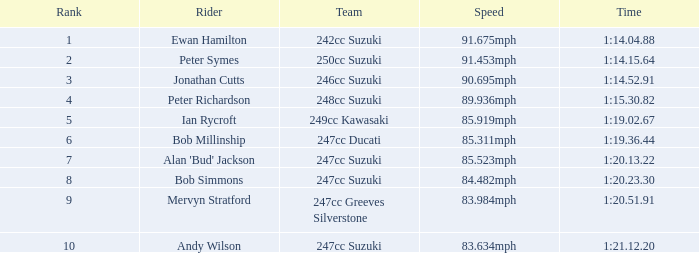0 242cc Suzuki. 